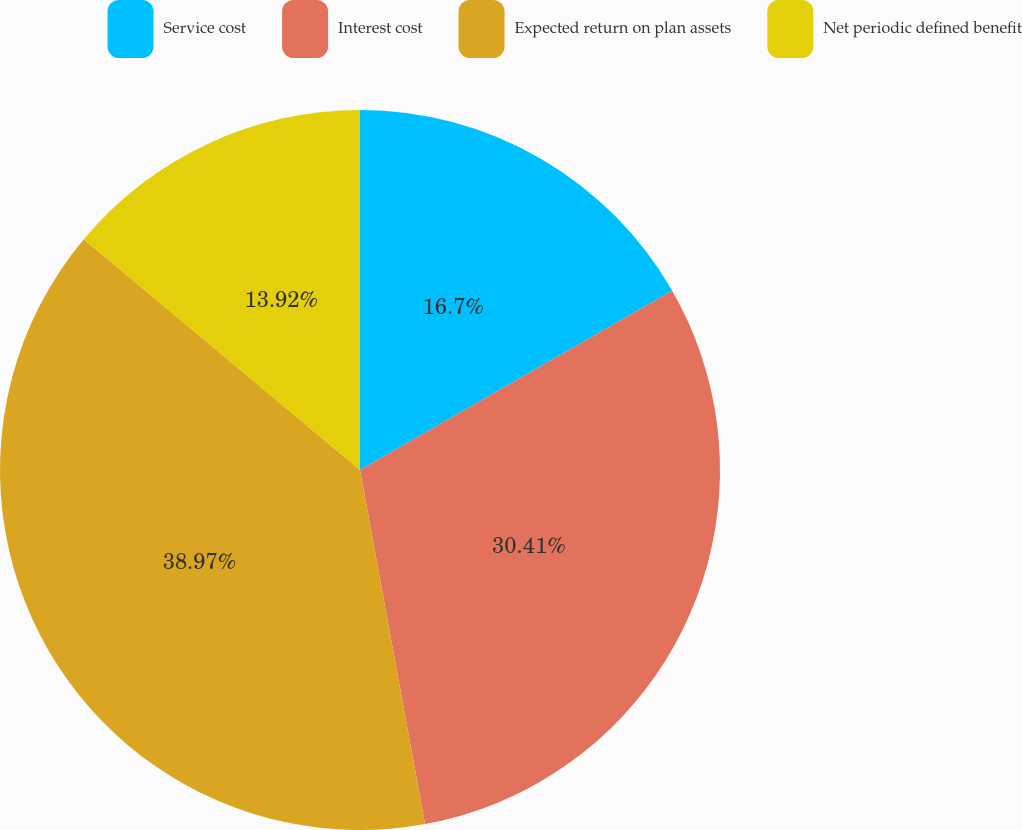Convert chart. <chart><loc_0><loc_0><loc_500><loc_500><pie_chart><fcel>Service cost<fcel>Interest cost<fcel>Expected return on plan assets<fcel>Net periodic defined benefit<nl><fcel>16.7%<fcel>30.41%<fcel>38.97%<fcel>13.92%<nl></chart> 